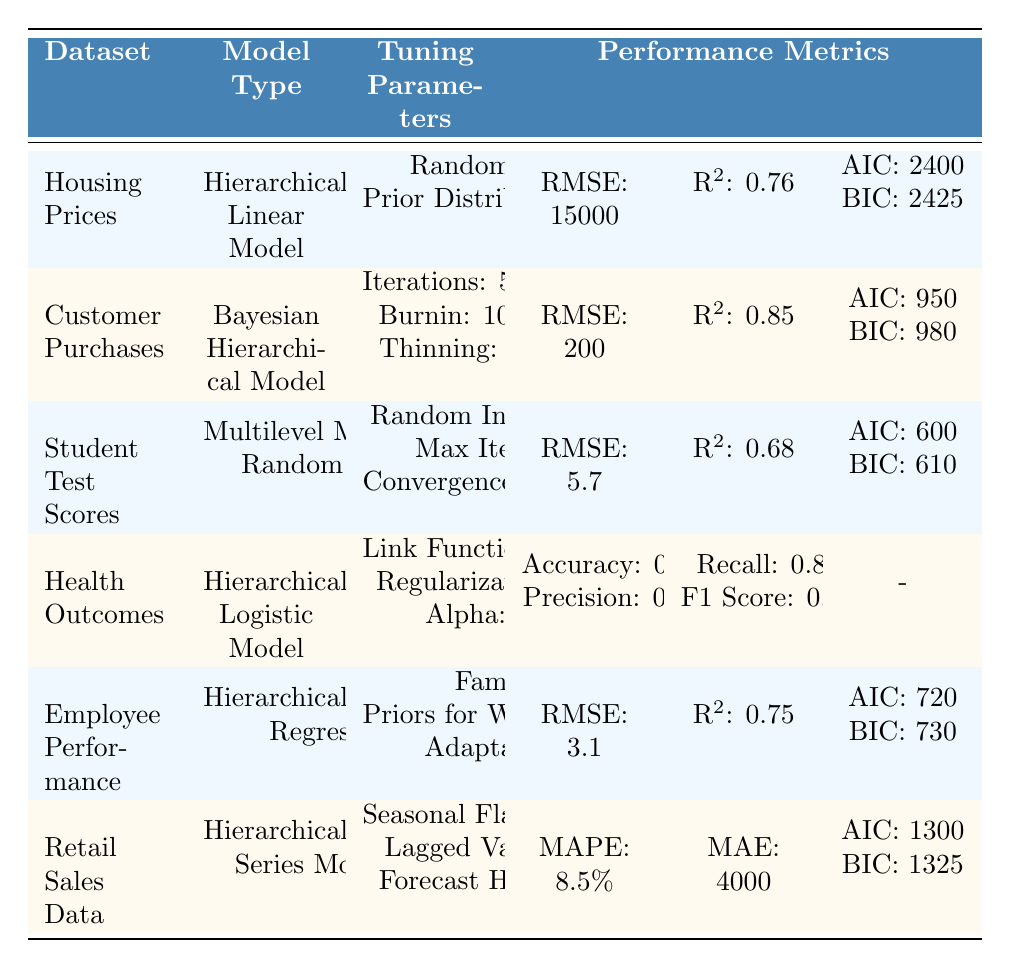What is the RMSE for the Bayesian Hierarchical Model on Customer Purchases? The RMSE value corresponding to the Bayesian Hierarchical Model in the Customer Purchases dataset is provided in the table. It states RMSE: 200 for this model.
Answer: 200 Which model has the highest R² value? By examining the R² values for each model listed in the table, the Bayesian Hierarchical Model for Customer Purchases has the highest R² value of 0.85.
Answer: 0.85 Does the Hierarchical Logistic Model use a Logit link function? The tuning parameters for the Hierarchical Logistic Model indicate that the Link Function is indeed Logit.
Answer: Yes What is the difference in AIC between the Hierarchical Linear Model and the Hierarchical Time Series Model? The AIC for the Hierarchical Linear Model is 2400 and for the Hierarchical Time Series Model it is 1300. The difference is 2400 - 1300 = 1100.
Answer: 1100 What is the mean RMSE across all listed models? To find the mean RMSE, we first identify the RMSE values: 15000, 200, 5.7, 3.1, and the Hierarchical Time Series Model has no RMSE value but has MAPE instead. We sum the RMSE values: 15000 + 200 + 5.7 + 3.1 = 15208. We count the models with RMSE, which are 4. Therefore, the mean RMSE = 15208 / 4 = 3802.
Answer: 3802 Which model yielded the best Accuracy score, and what is that score? By reviewing the performance metrics for the models, the Hierarchical Logistic Model shows an Accuracy score of 0.90, which is the highest among the models listed.
Answer: 0.90 For how many datasets is the R² value provided in this table? The R² values are provided for three datasets in the table: Housing Prices, Customer Purchases, and Employee Performance. Therefore, the count is 3.
Answer: 3 If we consider the models listed, which one has the lowest RMSE value? The model with the lowest RMSE value is the Hierarchical Bayesian Regression for Employee Performance, with an RMSE of 3.1.
Answer: 3.1 What is the total number of tuning parameters listed for the Health Outcomes model? The Health Outcomes model lists three tuning parameters: Link Function, Regularization, and Alpha. Thus, the total is 3.
Answer: 3 Which model has the highest F1 Score and what is that score? The F1 Score is provided only for the Hierarchical Logistic Model, which has an F1 Score of 0.82, making it the highest as it's the only model with this metric.
Answer: 0.82 What are the AIC and BIC values for the Student Test Scores dataset? The AIC value for the Student Test Scores dataset is 600, and the BIC value is 610, as specified in the performance metrics section for this dataset.
Answer: AIC: 600, BIC: 610 